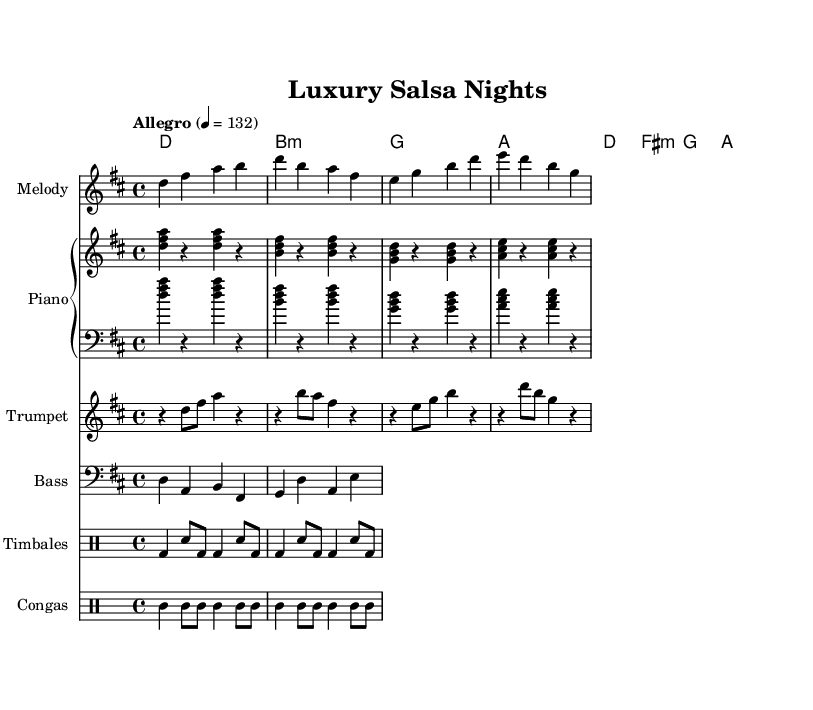What is the key signature of this music? The key signature is D major, which has two sharps (F# and C#).
Answer: D major What is the time signature of this music? The time signature is 4/4, indicating four beats per measure.
Answer: 4/4 What is the tempo marking for this piece? The tempo marking is "Allegro," indicating a fast and lively pace, set at 132 beats per minute.
Answer: Allegro How many distinct instruments are notated in this sheet music? There are five distinct instruments notated: Melody, Piano, Trumpet, Bass, and two different Drum instruments (Timbales and Congas), totaling six.
Answer: Six Which section features rhythms typical of salsa music? The sections for the Timbales and Congas feature rhythms that are characteristic of salsa music, as they use syncopated patterns and emulate Latin percussion styles.
Answer: Timbales and Congas What is the highest note in the melody? The highest note in the melody is B, which occurs in the first measure.
Answer: B 